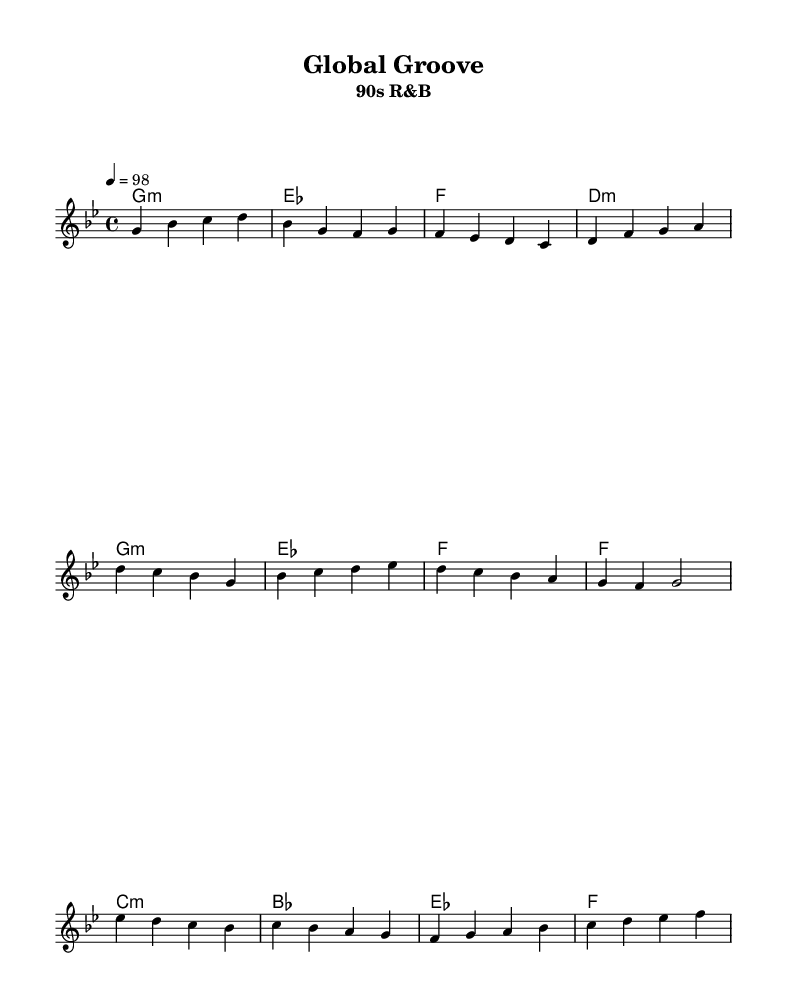What is the key signature of this music? The key signature is G minor, which has two flats.
Answer: G minor What is the time signature of the piece? The time signature is 4/4, indicating four beats per measure.
Answer: 4/4 What is the tempo marking for this piece? The tempo marking is 98 beats per minute, specified with a quarter note equals 98.
Answer: 98 How many measures are in the verse section? The verse section consists of four measures, as determined by the grouping of notes and bars.
Answer: Four measures Which chord follows the G minor chord in the verse? The chord following G minor is E flat major, as shown in the chord progression.
Answer: E flat major What type of song structure is used in this piece? The structure includes verses, a chorus, and a bridge, typical of many Rhythm and blues songs.
Answer: Verse-chorus-bridge What lyrical theme is suggested in the chorus? The lyrics suggest a theme of love that transcends borders and locations, expressing a deep connection.
Answer: Love transcends borders 